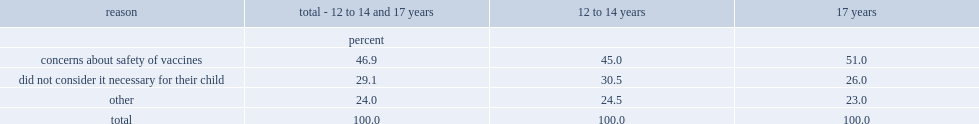What was the most commonly reported main reason for not vaccinating a child aged 12 to 14 and 17 against hpv and what is the percentage of that reason? 46.9. What was the second commonly reported main reason for not vaccinating a child aged 12 to 14 and 17 against hpv and what is the percentage of that reason? 29.1. 